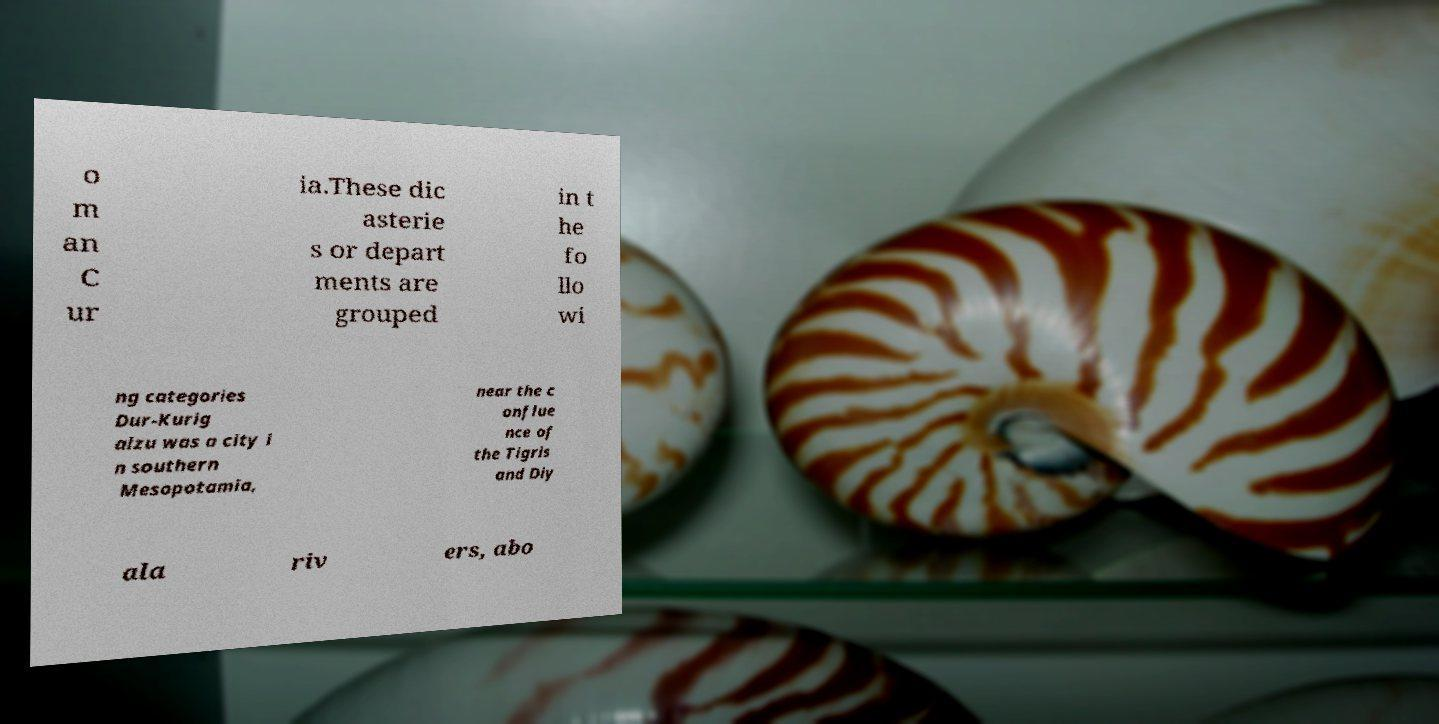For documentation purposes, I need the text within this image transcribed. Could you provide that? o m an C ur ia.These dic asterie s or depart ments are grouped in t he fo llo wi ng categories Dur-Kurig alzu was a city i n southern Mesopotamia, near the c onflue nce of the Tigris and Diy ala riv ers, abo 